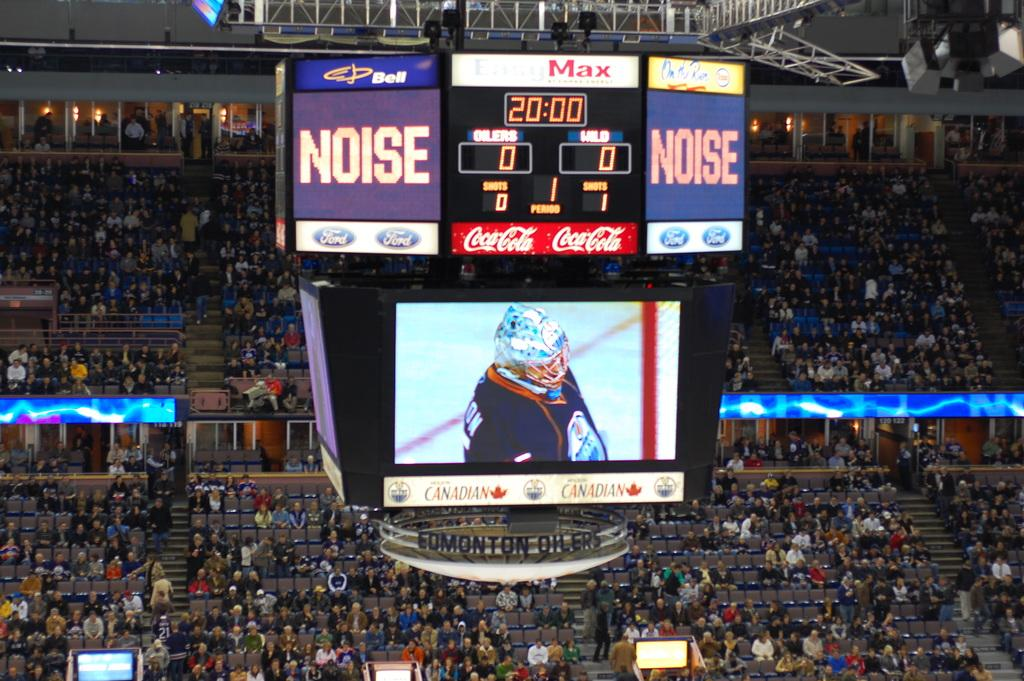<image>
Relay a brief, clear account of the picture shown. a scoreboard in a stadium that says 'noise' on either side 